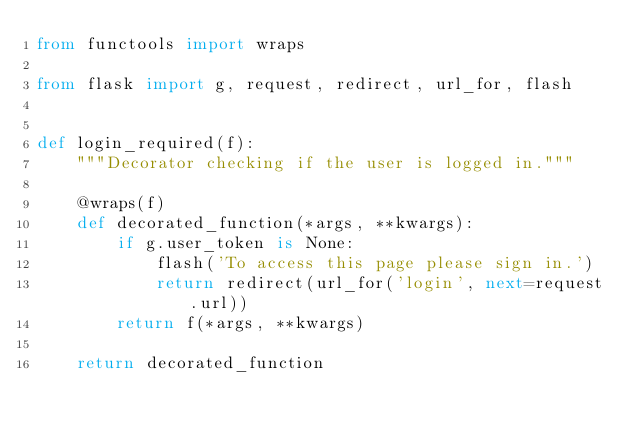Convert code to text. <code><loc_0><loc_0><loc_500><loc_500><_Python_>from functools import wraps

from flask import g, request, redirect, url_for, flash


def login_required(f):
    """Decorator checking if the user is logged in."""

    @wraps(f)
    def decorated_function(*args, **kwargs):
        if g.user_token is None:
            flash('To access this page please sign in.')
            return redirect(url_for('login', next=request.url))
        return f(*args, **kwargs)

    return decorated_function
</code> 